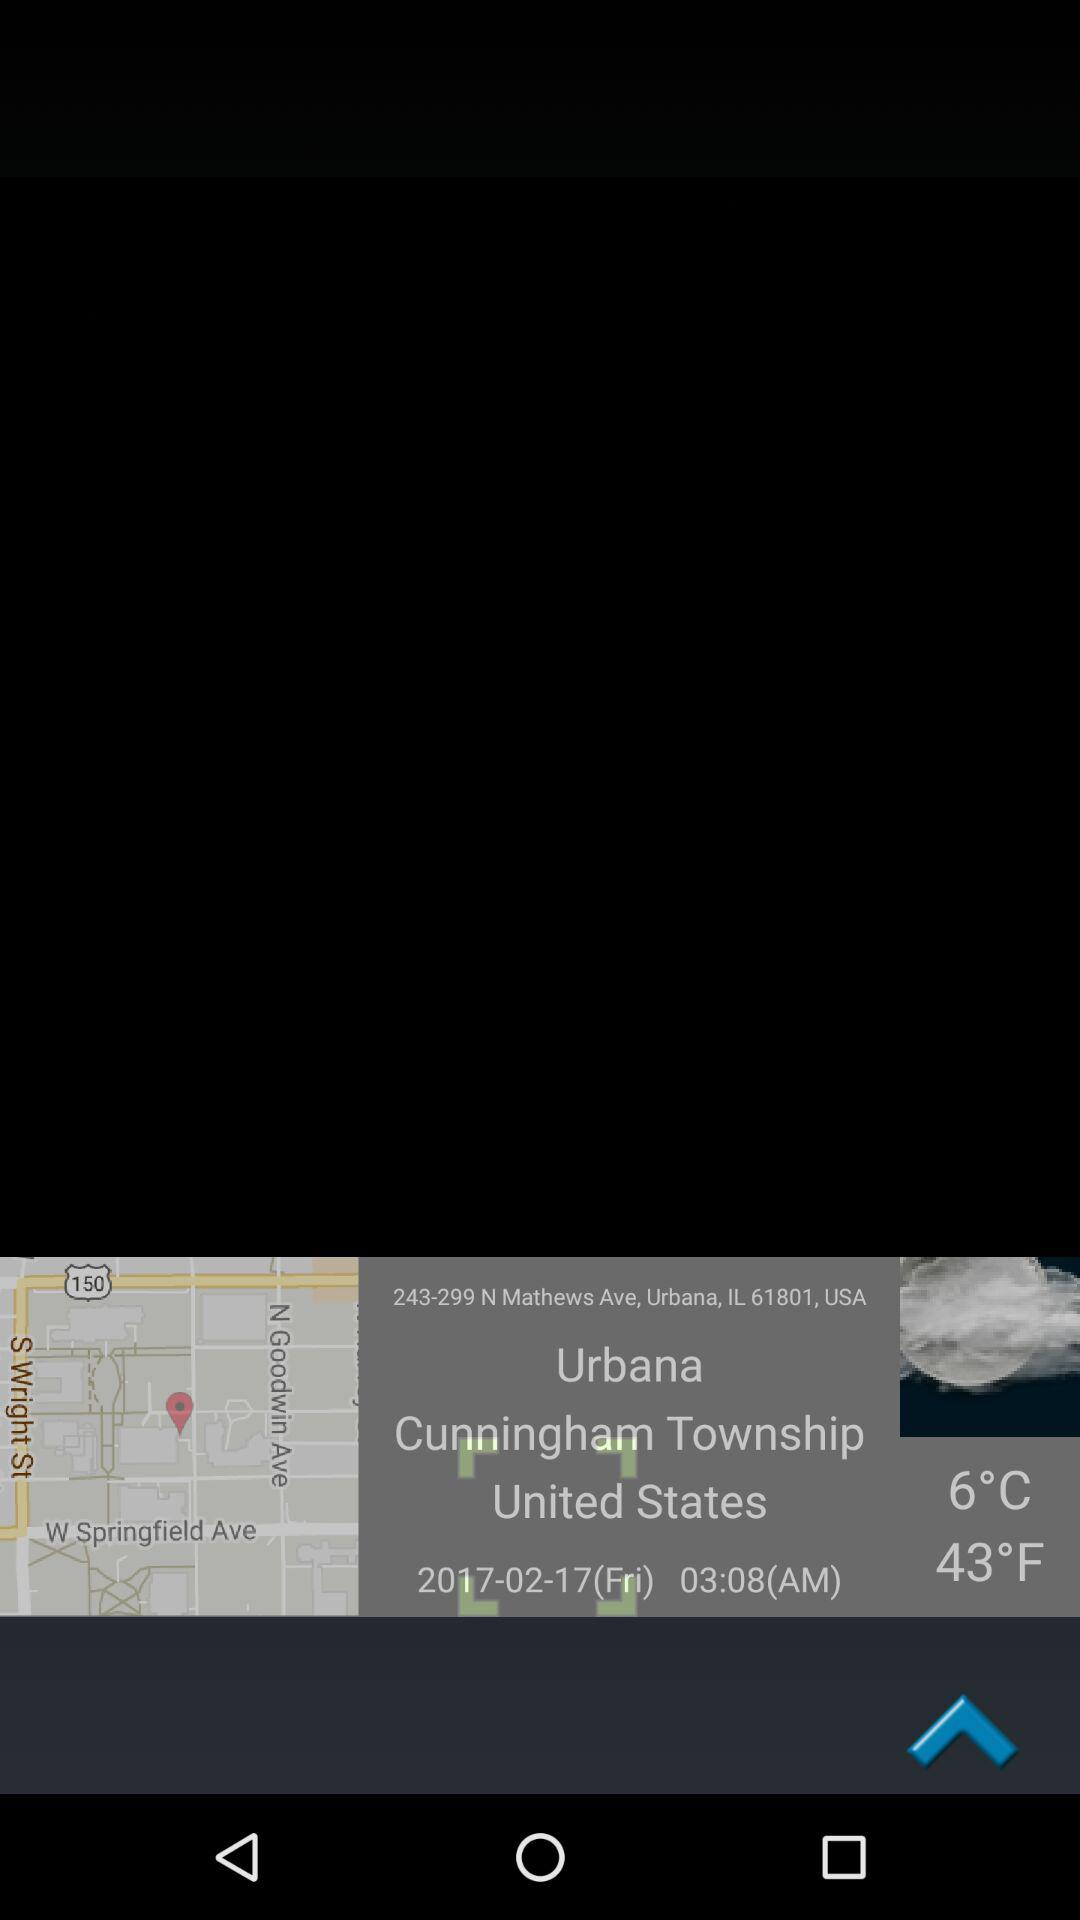What is the given temperature? The given temperature is 6°C. 